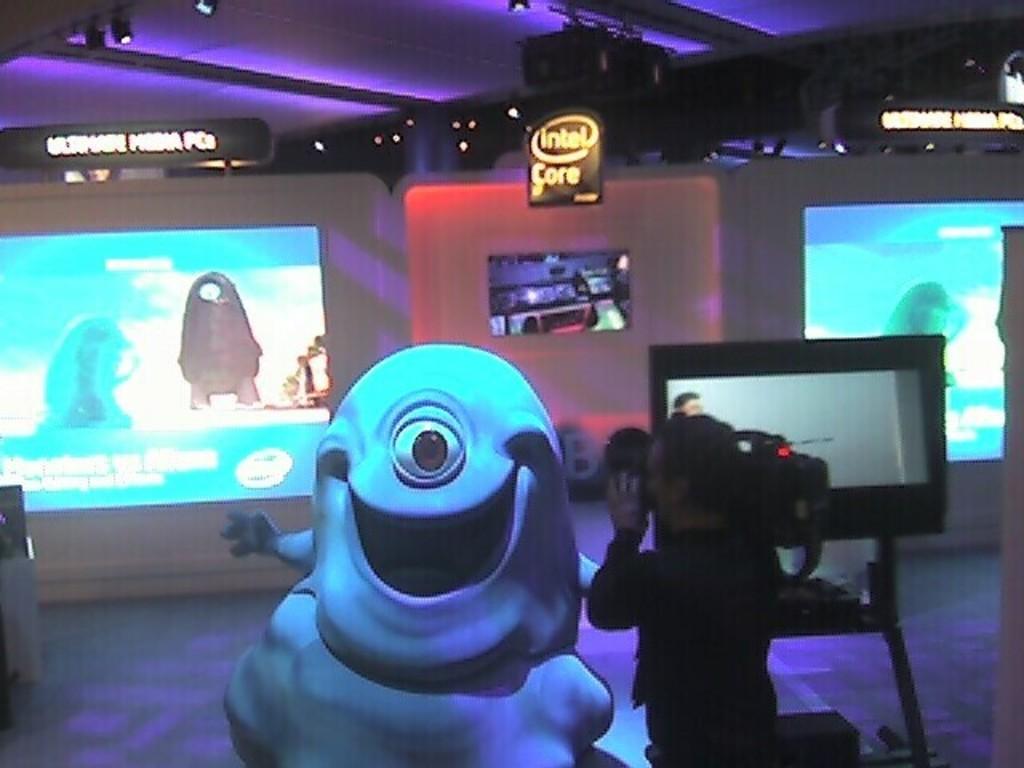What does the sign near the ceiling say?
Provide a short and direct response. Intel core. How many eyes does the monster have?
Your answer should be compact. Answering does not require reading text in the image. 